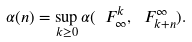<formula> <loc_0><loc_0><loc_500><loc_500>\alpha ( n ) = \sup _ { k \geq 0 } \alpha ( \ F _ { \infty } ^ { k } , \ F _ { k + n } ^ { \infty } ) .</formula> 